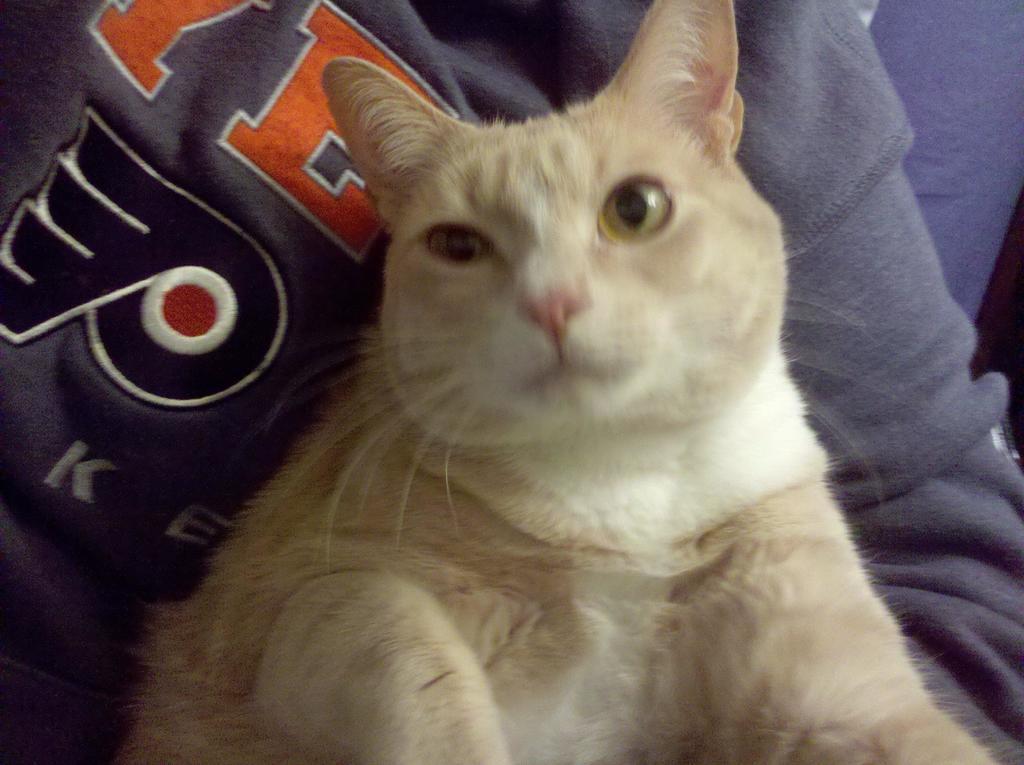How would you summarize this image in a sentence or two? In this image, I can see a cat sitting, which is white in color. I think this is a person. 